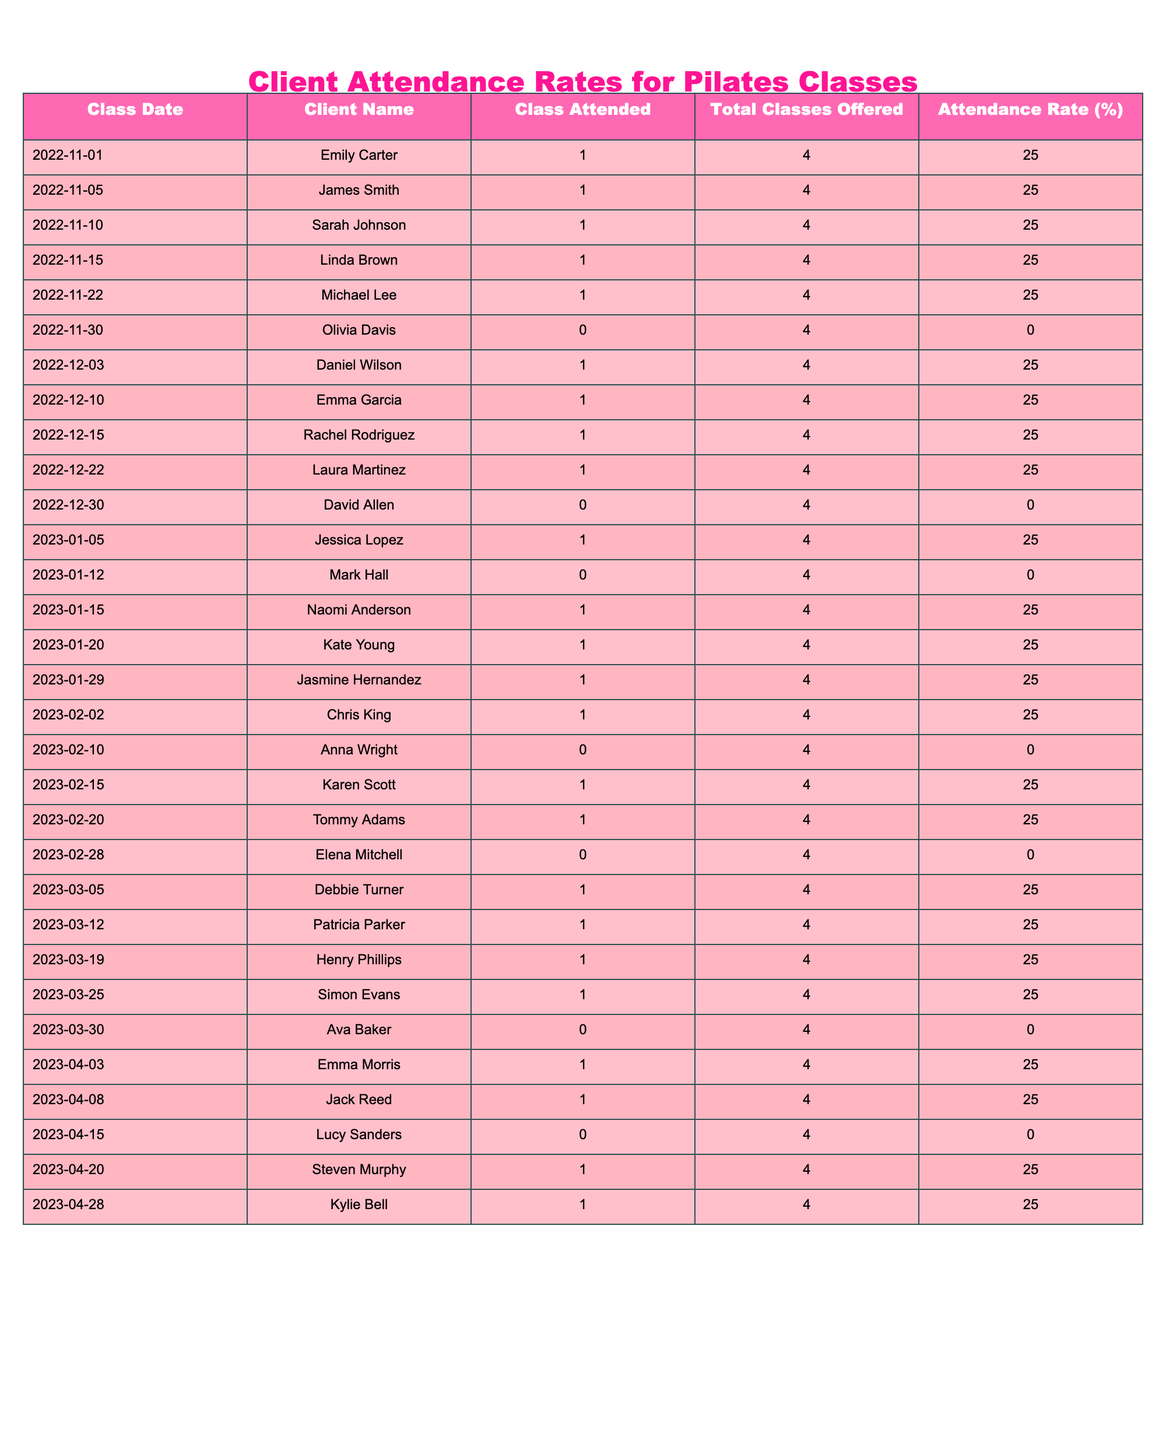What was the attendance rate for Naomi Anderson? Looking at the table, I search for Naomi Anderson's name and find her attendance rate listed under the "Attendance Rate (%)" column. She attended a class on 2023-01-15 with an attendance rate of 25%.
Answer: 25% How many total classes did Rachel Rodriguez attend? Reviewing the data for Rachel Rodriguez, there is one entry showing she attended class on 2022-12-15. Since attendance records indicate she attended that session, the total is 1 class.
Answer: 1 What percentage of classes was missed by Emily Carter? Emily Carter attended 1 out of 4 total classes. To calculate the percentage of missed classes, I subtract the attended classes from the total classes: 4 - 1 = 3 missed classes. The percentage missed would be (3/4) * 100 = 75%.
Answer: 75% Did Michael Lee attend any classes in November? I check the records for the month of November and find that Michael Lee attended a class on 2022-11-22, which confirms that he did attend classes in November.
Answer: Yes What is the average attendance rate across all clients in December? I gather all attendance rates from December: 25% (Daniel), 25% (Emma), 25% (Rachel), 25% (Laura), and 0% (David). I sum them up: 25 + 25 + 25 + 25 + 0 = 100. There are 5 entries, so the average attendance is 100 / 5 = 20%.
Answer: 20% How many times did clients attend classes on the last day of the month? Looking at the table, I check the entries for the last day of each month represented. In November, 0 (Olivia); December, 0 (David); January, 0 (Mark); February, 0 (Elena); March, 0 (Ava); and April, 0 (Lucy). Therefore, all entries indicate no attendance.
Answer: 0 Which client had the highest number of attended classes? I have to check the names in the table for each client's attendance records over the entire dataset. By reviewing the records, I see that no clients attended more than one class within the sampled months. Thus, no single client can be identified as having a higher attendance than another.
Answer: No client had more than one attendance What was the total number of classes offered in April? Experiencing through April's entries, I see there were 5 classes offered. Each entry for the month shows a total of 4 so I can conclude that 4 classes were consistently offered across the month.
Answer: 4 